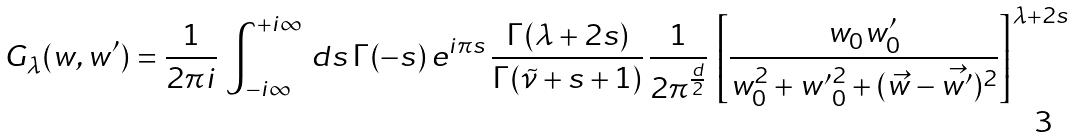Convert formula to latex. <formula><loc_0><loc_0><loc_500><loc_500>G _ { \lambda } ( w , w ^ { \prime } ) = \frac { 1 } { 2 \pi i } \, \int _ { - i \infty } ^ { + i \infty } \, d s \, \Gamma ( - s ) \, e ^ { i \pi s } \, \frac { \Gamma ( \lambda + 2 s ) } { \Gamma ( \tilde { \nu } + s + 1 ) } \, \frac { 1 } { 2 \pi ^ { \frac { d } { 2 } } } \, \left [ \frac { w _ { 0 } w ^ { \prime } _ { 0 } } { w _ { 0 } ^ { 2 } + { w ^ { \prime } } _ { 0 } ^ { 2 } + ( \vec { w } - \vec { w ^ { \prime } } ) ^ { 2 } } \right ] ^ { \lambda + 2 s }</formula> 